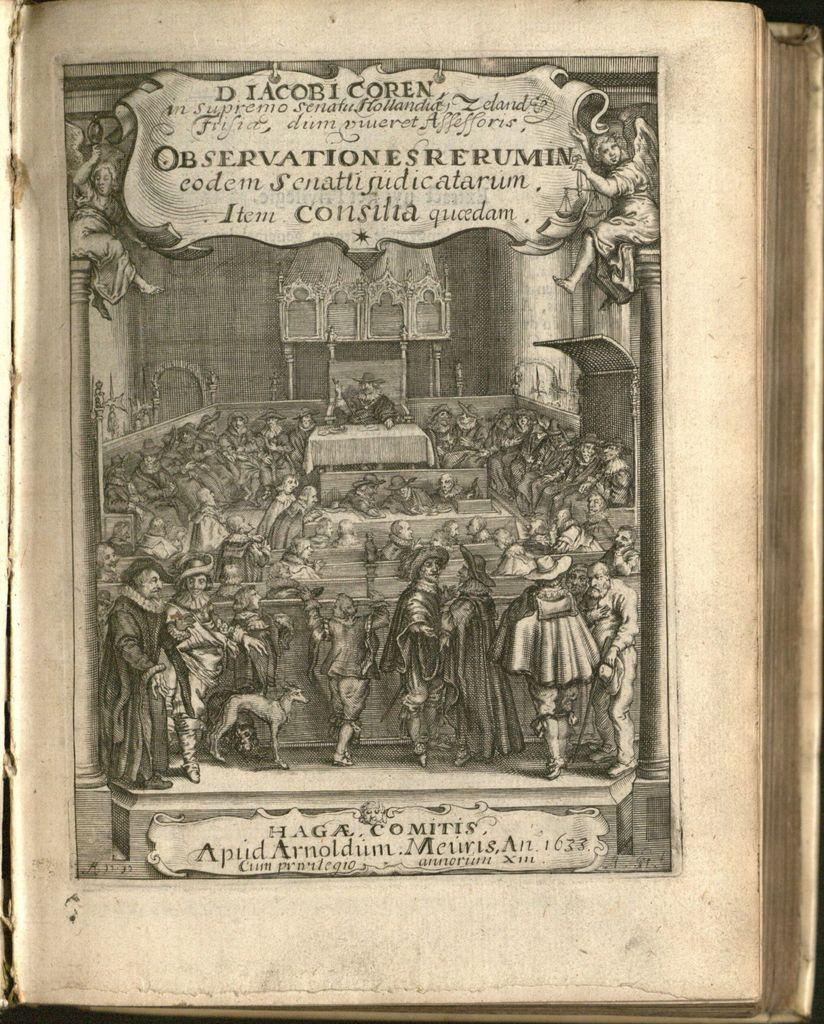<image>
Create a compact narrative representing the image presented. An old picture says Observationes Rerumin on top of it. 